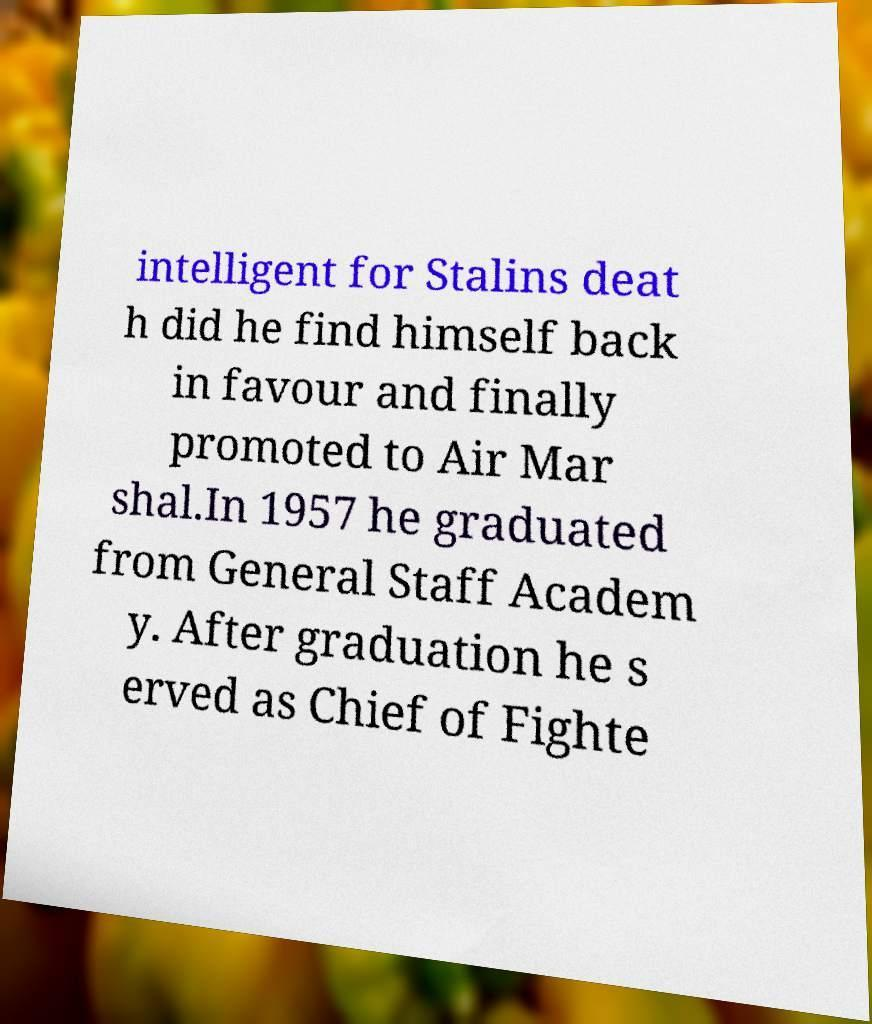Please identify and transcribe the text found in this image. intelligent for Stalins deat h did he find himself back in favour and finally promoted to Air Mar shal.In 1957 he graduated from General Staff Academ y. After graduation he s erved as Chief of Fighte 